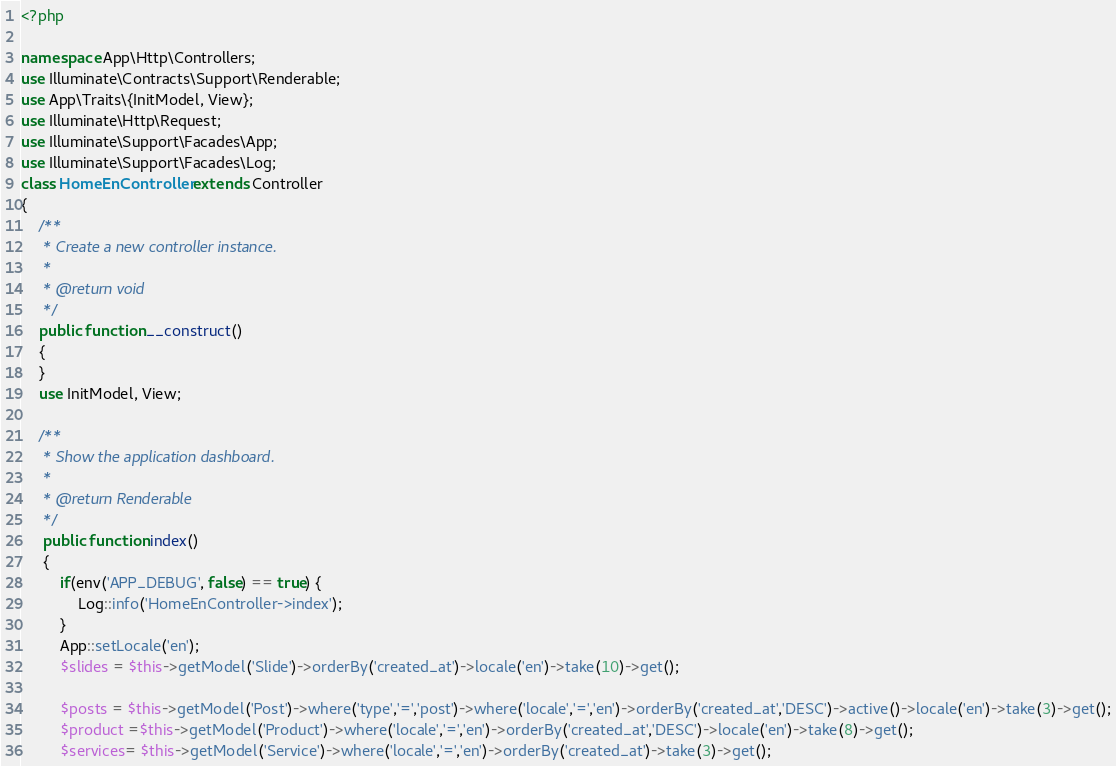Convert code to text. <code><loc_0><loc_0><loc_500><loc_500><_PHP_><?php

namespace App\Http\Controllers;
use Illuminate\Contracts\Support\Renderable;
use App\Traits\{InitModel, View};
use Illuminate\Http\Request;
use Illuminate\Support\Facades\App;
use Illuminate\Support\Facades\Log;
class HomeEnController extends Controller
{
    /**
     * Create a new controller instance.
     *
     * @return void
     */
    public function __construct()
    {
    }
    use InitModel, View;

    /**
     * Show the application dashboard.
     *
     * @return Renderable
     */
     public function index()
     {
         if(env('APP_DEBUG', false) == true) {
             Log::info('HomeEnController->index');
         }
         App::setLocale('en');
         $slides = $this->getModel('Slide')->orderBy('created_at')->locale('en')->take(10)->get();

         $posts = $this->getModel('Post')->where('type','=','post')->where('locale','=','en')->orderBy('created_at','DESC')->active()->locale('en')->take(3)->get();
         $product =$this->getModel('Product')->where('locale','=','en')->orderBy('created_at','DESC')->locale('en')->take(8)->get();
         $services= $this->getModel('Service')->where('locale','=','en')->orderBy('created_at')->take(3)->get();</code> 